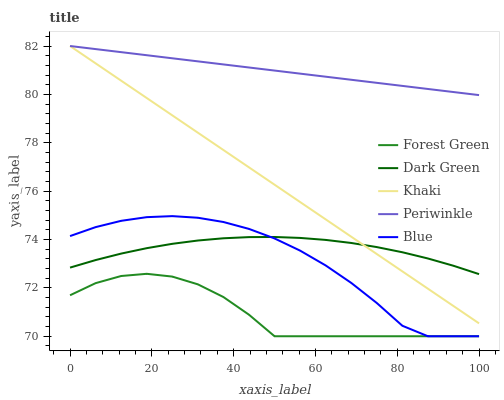Does Forest Green have the minimum area under the curve?
Answer yes or no. Yes. Does Periwinkle have the maximum area under the curve?
Answer yes or no. Yes. Does Khaki have the minimum area under the curve?
Answer yes or no. No. Does Khaki have the maximum area under the curve?
Answer yes or no. No. Is Khaki the smoothest?
Answer yes or no. Yes. Is Forest Green the roughest?
Answer yes or no. Yes. Is Forest Green the smoothest?
Answer yes or no. No. Is Khaki the roughest?
Answer yes or no. No. Does Blue have the lowest value?
Answer yes or no. Yes. Does Khaki have the lowest value?
Answer yes or no. No. Does Periwinkle have the highest value?
Answer yes or no. Yes. Does Forest Green have the highest value?
Answer yes or no. No. Is Forest Green less than Khaki?
Answer yes or no. Yes. Is Khaki greater than Forest Green?
Answer yes or no. Yes. Does Dark Green intersect Khaki?
Answer yes or no. Yes. Is Dark Green less than Khaki?
Answer yes or no. No. Is Dark Green greater than Khaki?
Answer yes or no. No. Does Forest Green intersect Khaki?
Answer yes or no. No. 